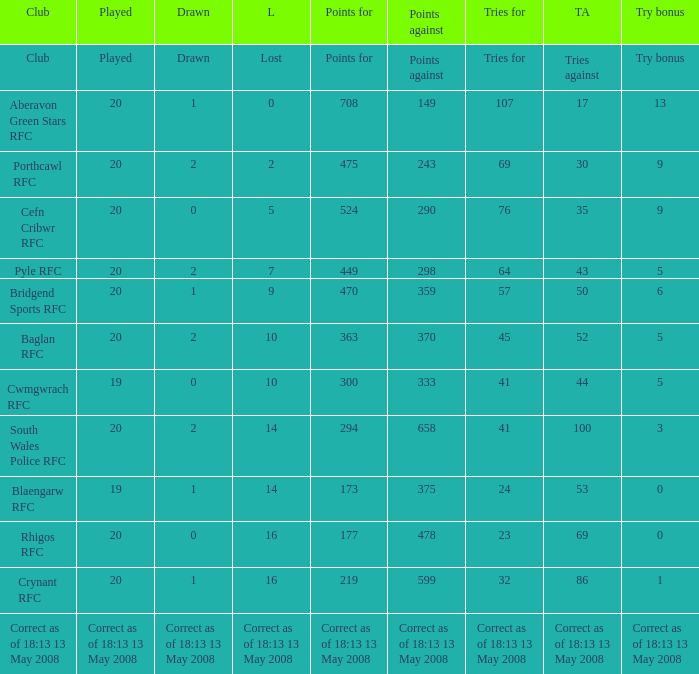Could you help me parse every detail presented in this table? {'header': ['Club', 'Played', 'Drawn', 'L', 'Points for', 'Points against', 'Tries for', 'TA', 'Try bonus'], 'rows': [['Club', 'Played', 'Drawn', 'Lost', 'Points for', 'Points against', 'Tries for', 'Tries against', 'Try bonus'], ['Aberavon Green Stars RFC', '20', '1', '0', '708', '149', '107', '17', '13'], ['Porthcawl RFC', '20', '2', '2', '475', '243', '69', '30', '9'], ['Cefn Cribwr RFC', '20', '0', '5', '524', '290', '76', '35', '9'], ['Pyle RFC', '20', '2', '7', '449', '298', '64', '43', '5'], ['Bridgend Sports RFC', '20', '1', '9', '470', '359', '57', '50', '6'], ['Baglan RFC', '20', '2', '10', '363', '370', '45', '52', '5'], ['Cwmgwrach RFC', '19', '0', '10', '300', '333', '41', '44', '5'], ['South Wales Police RFC', '20', '2', '14', '294', '658', '41', '100', '3'], ['Blaengarw RFC', '19', '1', '14', '173', '375', '24', '53', '0'], ['Rhigos RFC', '20', '0', '16', '177', '478', '23', '69', '0'], ['Crynant RFC', '20', '1', '16', '219', '599', '32', '86', '1'], ['Correct as of 18:13 13 May 2008', 'Correct as of 18:13 13 May 2008', 'Correct as of 18:13 13 May 2008', 'Correct as of 18:13 13 May 2008', 'Correct as of 18:13 13 May 2008', 'Correct as of 18:13 13 May 2008', 'Correct as of 18:13 13 May 2008', 'Correct as of 18:13 13 May 2008', 'Correct as of 18:13 13 May 2008']]} What is the tries against when the points are 475? 30.0. 